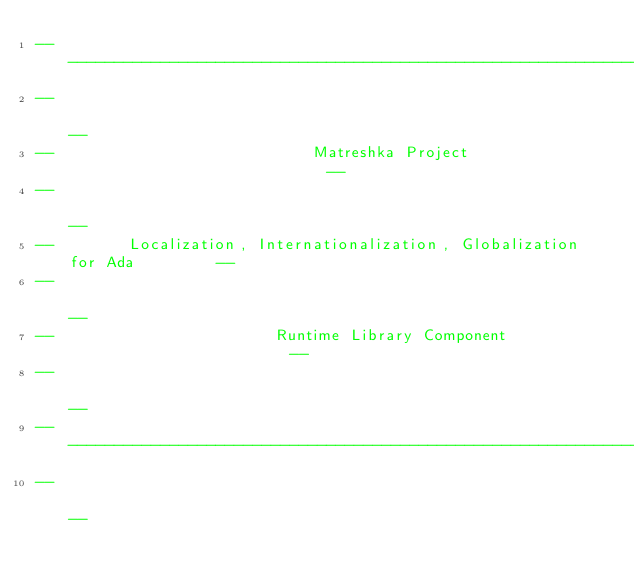Convert code to text. <code><loc_0><loc_0><loc_500><loc_500><_Ada_>------------------------------------------------------------------------------
--                                                                          --
--                            Matreshka Project                             --
--                                                                          --
--        Localization, Internationalization, Globalization for Ada         --
--                                                                          --
--                        Runtime Library Component                         --
--                                                                          --
------------------------------------------------------------------------------
--                                                                          --</code> 